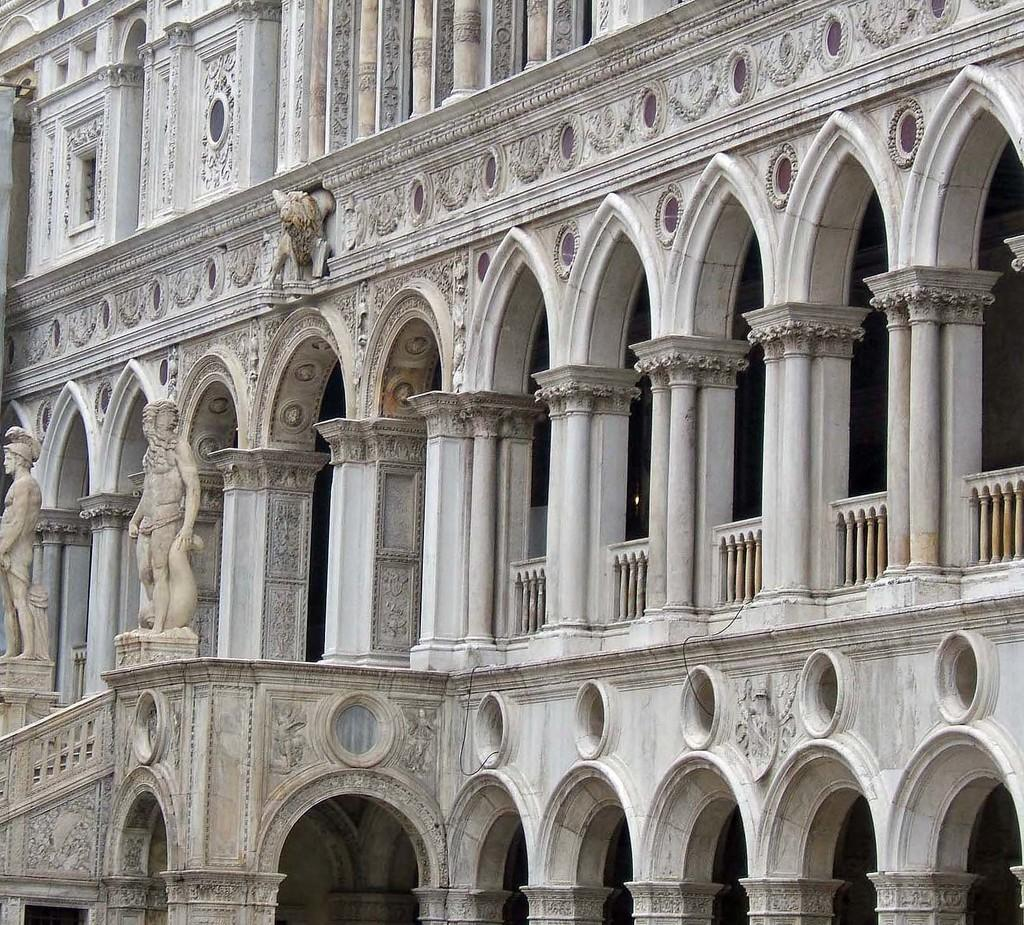What type of structure is visible in the picture? There is a building in the picture. What architectural feature can be seen on the building? The building has arches. Are there any other objects or figures present in the picture? Yes, there are statues present in the picture. What color are the babies' stockings in the picture? There are no babies or stockings present in the picture; it features a building with arches and statues. 